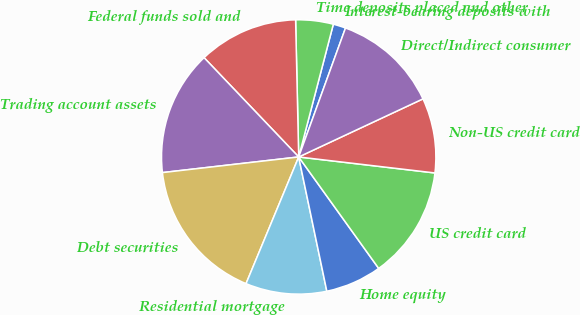Convert chart to OTSL. <chart><loc_0><loc_0><loc_500><loc_500><pie_chart><fcel>Interest-bearing deposits with<fcel>Time deposits placed and other<fcel>Federal funds sold and<fcel>Trading account assets<fcel>Debt securities<fcel>Residential mortgage<fcel>Home equity<fcel>US credit card<fcel>Non-US credit card<fcel>Direct/Indirect consumer<nl><fcel>1.48%<fcel>4.42%<fcel>11.76%<fcel>14.7%<fcel>16.91%<fcel>9.56%<fcel>6.62%<fcel>13.23%<fcel>8.82%<fcel>12.5%<nl></chart> 